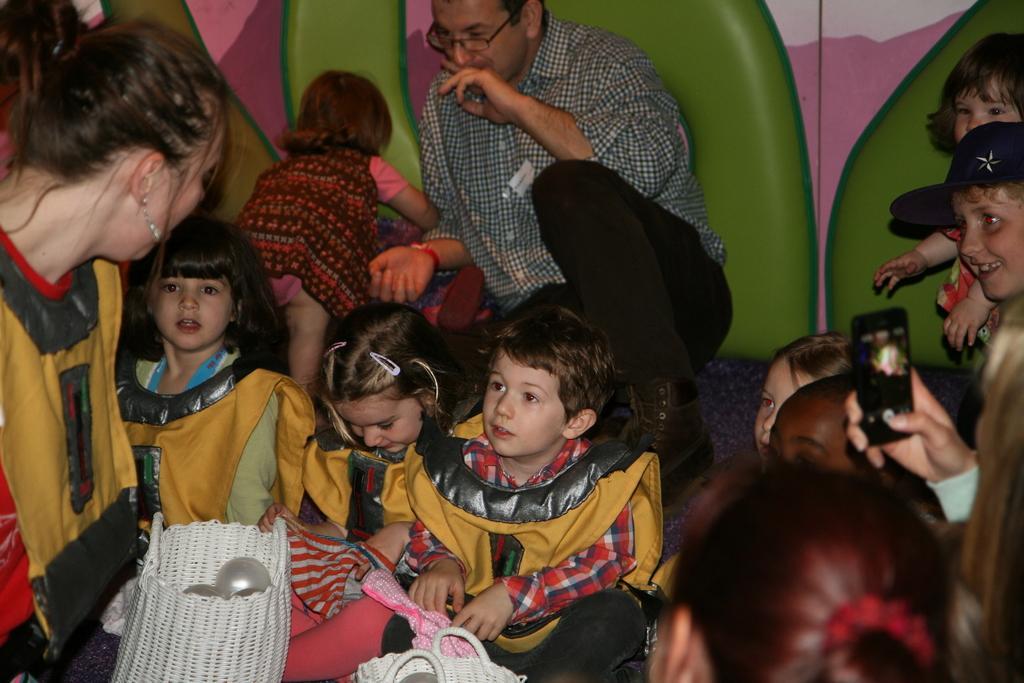Describe this image in one or two sentences. In this picture I can see children sitting on the surface. I can see people sitting on the surface. I can see a mobile phone in a person's hand. 